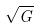<formula> <loc_0><loc_0><loc_500><loc_500>\sqrt { G }</formula> 